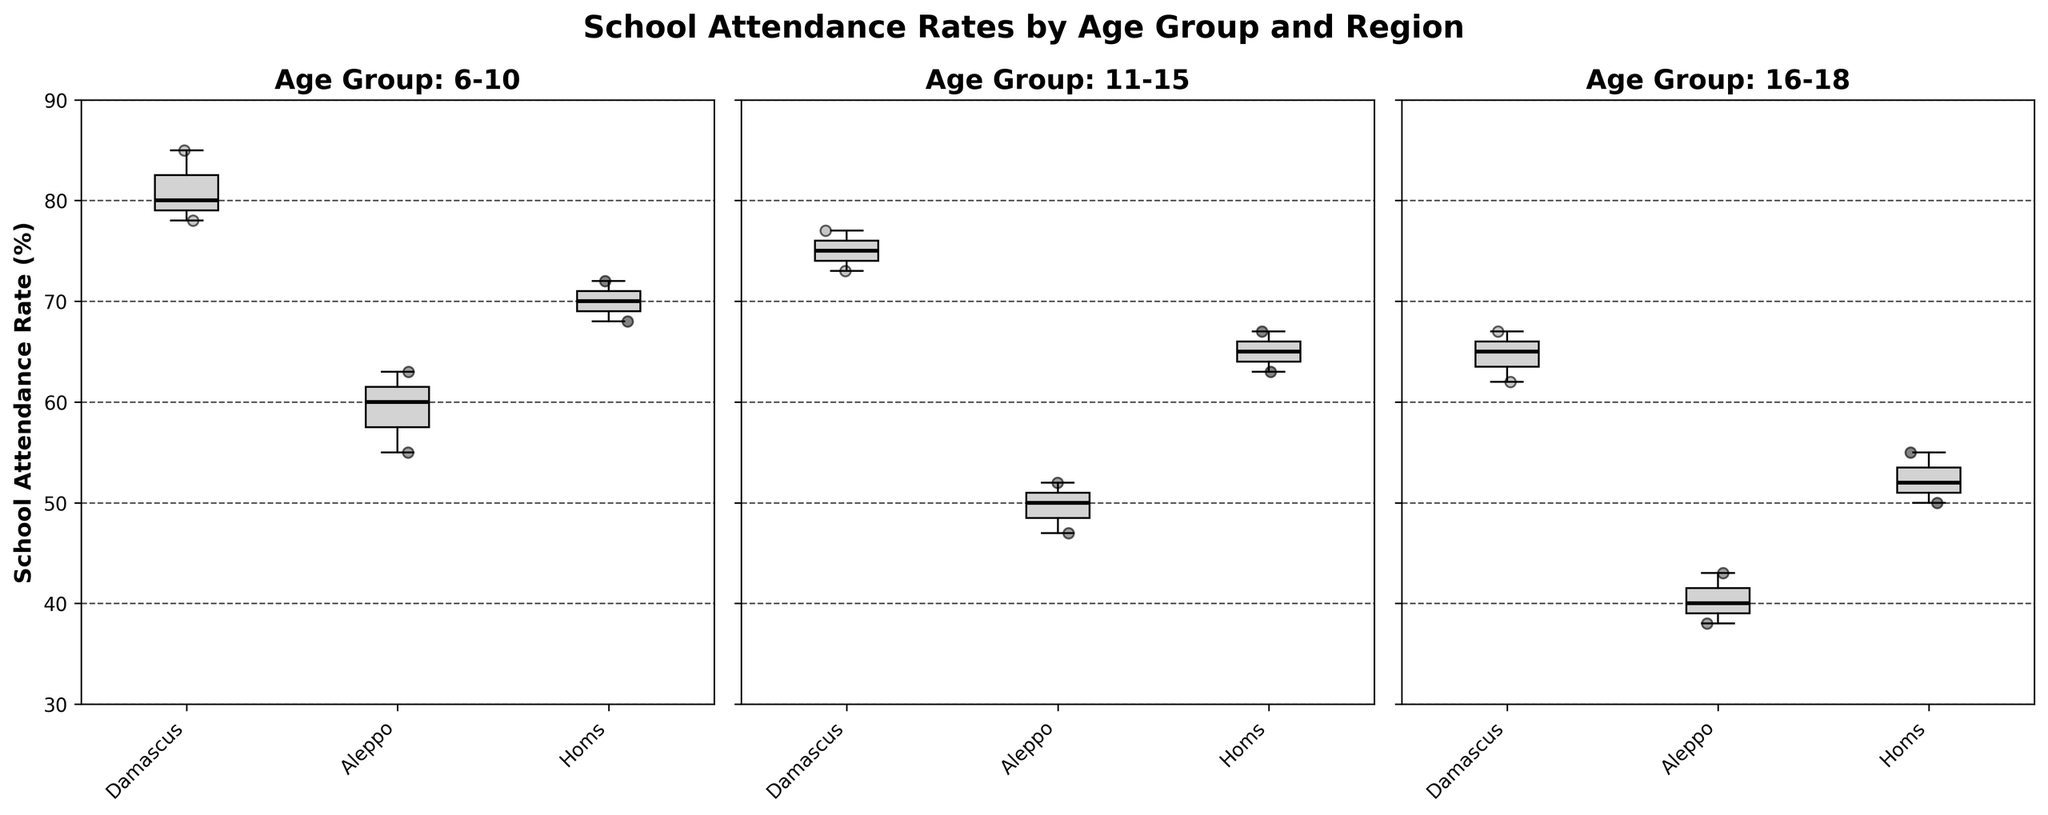What is the title of the figure? The title is positioned on top of the figure, which summarizes the plot's content. The title states the main subject of the figure.
Answer: School Attendance Rates by Age Group and Region Which age group appears to have the highest median school attendance rate? To determine this, look at the line that represents the median within the box of each plot and identify the highest one. Compare the median lines of 6-10, 11-15, and 16-18 age groups.
Answer: 6-10 What is the range of school attendance rates for the 6-10 age group in Aleppo? The range is identified by the whiskers (the lines that extend from the bottom and top of the box) for the Aleppo box plot in the 6-10 age group. The range spans from the minimum to the maximum values within the whiskers.
Answer: 55-63 Compare the school attendance rate distributions for the 11-15 age group between Damascus and Aleppo. Look at the position of the boxes and whiskers for these regions within the 11-15 age group subplot. Compare the median lines, the spread of the boxes, and the whiskers. Damascus has a higher median and a smaller spread than Aleppo.
Answer: Higher in Damascus with less spread In which region and for which age group is the lowest median attendance rate observed? Find the lowest median line across all the boxes in all the plots. Notice the position of the median line within the box and identify the corresponding region and age group.
Answer: Aleppo, 16-18 What is the interquartile range (IQR) of school attendance rates for the 6-10 age group in Homs? The IQR is the difference between the third quartile (top of the box) and the first quartile (bottom of the box). Look at the bottom and top box edges for Homs in the 6-10 age group. The bottom edge is at 68 and the top edge is at 72.
Answer: 4 How do the attendance rates in Damascus change as the age group increases? Observe the median lines for Damascus across all age groups. Note the trend in the median values from 6-10 to 16-18 age groups. The median decreases from around 81 (6-10) to 75 (11-15), and further decreases to 64 (16-18).
Answer: Decreases Are there more outliers in the box plots of Aleppo compared to other regions for any age group? Outliers are typically points that extend outside the whiskers. Count the number of isolated points for Aleppo and compare with Damascus and Homs for each age group. No significant outliers are visible in the Aleppo data.
Answer: No Which region shows the smallest spread in school attendance rates for the 11-15 age group? Look at the width of the boxes and the lengths of the whiskers for each region in the 11-15 age group. Damascus has the tightest box with the smallest interquartile range (IQR), indicating the smallest spread.
Answer: Damascus What is the general trend observed in school attendance rates comparing Damascus, Aleppo, and Homs across all age groups? Note the positions of the boxes and medians for each region across the different age groups. Damascus usually has the highest attendance rates, followed by Homs and then Aleppo in descending order.
Answer: Highest in Damascus, followed by Homs, then Aleppo 